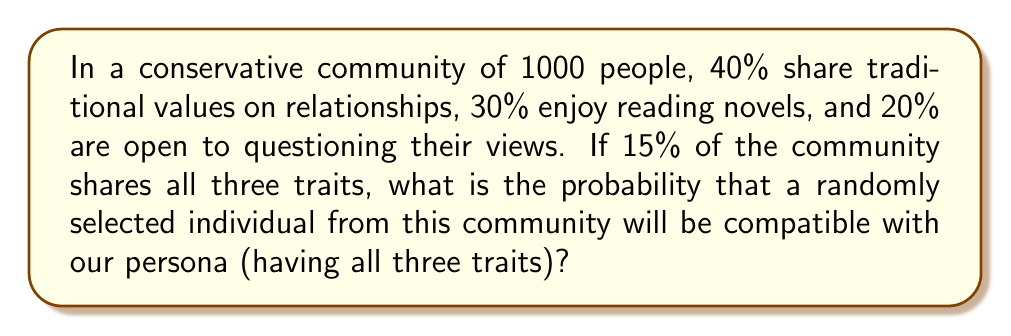Solve this math problem. Let's approach this step-by-step:

1) Define our events:
   A: Person shares traditional values on relationships
   B: Person enjoys reading novels
   C: Person is open to questioning their views

2) Given probabilities:
   P(A) = 40% = 0.4
   P(B) = 30% = 0.3
   P(C) = 20% = 0.2
   P(A ∩ B ∩ C) = 15% = 0.15

3) We need to find P(A ∩ B ∩ C), which is already given as 0.15.

4) To convert this to a probability, we simply need to express it as a decimal:

   $$P(\text{compatible}) = P(A ∩ B ∩ C) = 0.15$$

5) This means that out of the 1000 people in the community, 150 would be compatible with our persona.

6) Therefore, the probability of randomly selecting a compatible individual is 0.15 or 15%.
Answer: 0.15 